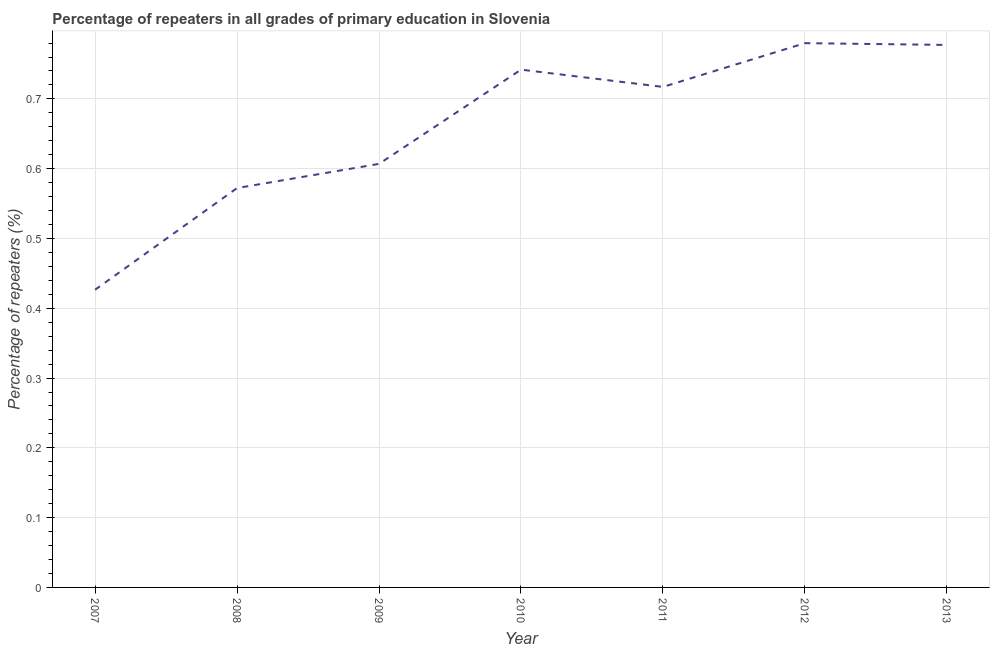What is the percentage of repeaters in primary education in 2009?
Provide a short and direct response. 0.61. Across all years, what is the maximum percentage of repeaters in primary education?
Provide a short and direct response. 0.78. Across all years, what is the minimum percentage of repeaters in primary education?
Make the answer very short. 0.43. In which year was the percentage of repeaters in primary education maximum?
Offer a terse response. 2012. What is the sum of the percentage of repeaters in primary education?
Ensure brevity in your answer.  4.62. What is the difference between the percentage of repeaters in primary education in 2010 and 2013?
Ensure brevity in your answer.  -0.04. What is the average percentage of repeaters in primary education per year?
Your answer should be compact. 0.66. What is the median percentage of repeaters in primary education?
Keep it short and to the point. 0.72. In how many years, is the percentage of repeaters in primary education greater than 0.30000000000000004 %?
Make the answer very short. 7. Do a majority of the years between 2013 and 2012 (inclusive) have percentage of repeaters in primary education greater than 0.56 %?
Provide a succinct answer. No. What is the ratio of the percentage of repeaters in primary education in 2008 to that in 2012?
Offer a terse response. 0.73. Is the difference between the percentage of repeaters in primary education in 2011 and 2012 greater than the difference between any two years?
Offer a very short reply. No. What is the difference between the highest and the second highest percentage of repeaters in primary education?
Offer a terse response. 0. What is the difference between the highest and the lowest percentage of repeaters in primary education?
Your answer should be very brief. 0.35. Are the values on the major ticks of Y-axis written in scientific E-notation?
Provide a short and direct response. No. What is the title of the graph?
Your response must be concise. Percentage of repeaters in all grades of primary education in Slovenia. What is the label or title of the Y-axis?
Provide a short and direct response. Percentage of repeaters (%). What is the Percentage of repeaters (%) of 2007?
Your answer should be compact. 0.43. What is the Percentage of repeaters (%) of 2008?
Ensure brevity in your answer.  0.57. What is the Percentage of repeaters (%) of 2009?
Provide a succinct answer. 0.61. What is the Percentage of repeaters (%) in 2010?
Your answer should be compact. 0.74. What is the Percentage of repeaters (%) of 2011?
Ensure brevity in your answer.  0.72. What is the Percentage of repeaters (%) of 2012?
Make the answer very short. 0.78. What is the Percentage of repeaters (%) of 2013?
Make the answer very short. 0.78. What is the difference between the Percentage of repeaters (%) in 2007 and 2008?
Ensure brevity in your answer.  -0.15. What is the difference between the Percentage of repeaters (%) in 2007 and 2009?
Offer a very short reply. -0.18. What is the difference between the Percentage of repeaters (%) in 2007 and 2010?
Offer a very short reply. -0.32. What is the difference between the Percentage of repeaters (%) in 2007 and 2011?
Your answer should be very brief. -0.29. What is the difference between the Percentage of repeaters (%) in 2007 and 2012?
Make the answer very short. -0.35. What is the difference between the Percentage of repeaters (%) in 2007 and 2013?
Make the answer very short. -0.35. What is the difference between the Percentage of repeaters (%) in 2008 and 2009?
Your answer should be very brief. -0.03. What is the difference between the Percentage of repeaters (%) in 2008 and 2010?
Provide a short and direct response. -0.17. What is the difference between the Percentage of repeaters (%) in 2008 and 2011?
Provide a succinct answer. -0.14. What is the difference between the Percentage of repeaters (%) in 2008 and 2012?
Make the answer very short. -0.21. What is the difference between the Percentage of repeaters (%) in 2008 and 2013?
Give a very brief answer. -0.21. What is the difference between the Percentage of repeaters (%) in 2009 and 2010?
Offer a terse response. -0.14. What is the difference between the Percentage of repeaters (%) in 2009 and 2011?
Ensure brevity in your answer.  -0.11. What is the difference between the Percentage of repeaters (%) in 2009 and 2012?
Make the answer very short. -0.17. What is the difference between the Percentage of repeaters (%) in 2009 and 2013?
Give a very brief answer. -0.17. What is the difference between the Percentage of repeaters (%) in 2010 and 2011?
Ensure brevity in your answer.  0.02. What is the difference between the Percentage of repeaters (%) in 2010 and 2012?
Offer a very short reply. -0.04. What is the difference between the Percentage of repeaters (%) in 2010 and 2013?
Provide a short and direct response. -0.04. What is the difference between the Percentage of repeaters (%) in 2011 and 2012?
Keep it short and to the point. -0.06. What is the difference between the Percentage of repeaters (%) in 2011 and 2013?
Your response must be concise. -0.06. What is the difference between the Percentage of repeaters (%) in 2012 and 2013?
Keep it short and to the point. 0. What is the ratio of the Percentage of repeaters (%) in 2007 to that in 2008?
Provide a succinct answer. 0.74. What is the ratio of the Percentage of repeaters (%) in 2007 to that in 2009?
Ensure brevity in your answer.  0.7. What is the ratio of the Percentage of repeaters (%) in 2007 to that in 2010?
Provide a short and direct response. 0.57. What is the ratio of the Percentage of repeaters (%) in 2007 to that in 2011?
Offer a terse response. 0.59. What is the ratio of the Percentage of repeaters (%) in 2007 to that in 2012?
Your response must be concise. 0.55. What is the ratio of the Percentage of repeaters (%) in 2007 to that in 2013?
Offer a very short reply. 0.55. What is the ratio of the Percentage of repeaters (%) in 2008 to that in 2009?
Your answer should be compact. 0.94. What is the ratio of the Percentage of repeaters (%) in 2008 to that in 2010?
Your answer should be very brief. 0.77. What is the ratio of the Percentage of repeaters (%) in 2008 to that in 2011?
Your answer should be compact. 0.8. What is the ratio of the Percentage of repeaters (%) in 2008 to that in 2012?
Offer a very short reply. 0.73. What is the ratio of the Percentage of repeaters (%) in 2008 to that in 2013?
Keep it short and to the point. 0.74. What is the ratio of the Percentage of repeaters (%) in 2009 to that in 2010?
Your answer should be very brief. 0.82. What is the ratio of the Percentage of repeaters (%) in 2009 to that in 2011?
Your answer should be compact. 0.85. What is the ratio of the Percentage of repeaters (%) in 2009 to that in 2012?
Provide a short and direct response. 0.78. What is the ratio of the Percentage of repeaters (%) in 2009 to that in 2013?
Your answer should be very brief. 0.78. What is the ratio of the Percentage of repeaters (%) in 2010 to that in 2011?
Offer a terse response. 1.03. What is the ratio of the Percentage of repeaters (%) in 2010 to that in 2012?
Ensure brevity in your answer.  0.95. What is the ratio of the Percentage of repeaters (%) in 2010 to that in 2013?
Ensure brevity in your answer.  0.95. What is the ratio of the Percentage of repeaters (%) in 2011 to that in 2012?
Make the answer very short. 0.92. What is the ratio of the Percentage of repeaters (%) in 2011 to that in 2013?
Give a very brief answer. 0.92. 